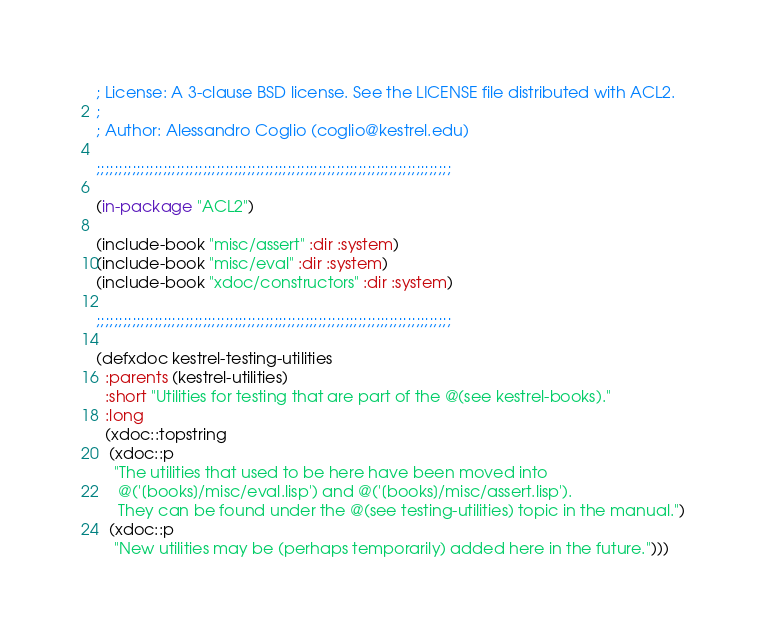<code> <loc_0><loc_0><loc_500><loc_500><_Lisp_>; License: A 3-clause BSD license. See the LICENSE file distributed with ACL2.
;
; Author: Alessandro Coglio (coglio@kestrel.edu)

;;;;;;;;;;;;;;;;;;;;;;;;;;;;;;;;;;;;;;;;;;;;;;;;;;;;;;;;;;;;;;;;;;;;;;;;;;;;;;;;

(in-package "ACL2")

(include-book "misc/assert" :dir :system)
(include-book "misc/eval" :dir :system)
(include-book "xdoc/constructors" :dir :system)

;;;;;;;;;;;;;;;;;;;;;;;;;;;;;;;;;;;;;;;;;;;;;;;;;;;;;;;;;;;;;;;;;;;;;;;;;;;;;;;;

(defxdoc kestrel-testing-utilities
  :parents (kestrel-utilities)
  :short "Utilities for testing that are part of the @(see kestrel-books)."
  :long
  (xdoc::topstring
   (xdoc::p
    "The utilities that used to be here have been moved into
     @('[books]/misc/eval.lisp') and @('[books]/misc/assert.lisp').
     They can be found under the @(see testing-utilities) topic in the manual.")
   (xdoc::p
    "New utilities may be (perhaps temporarily) added here in the future.")))
</code> 